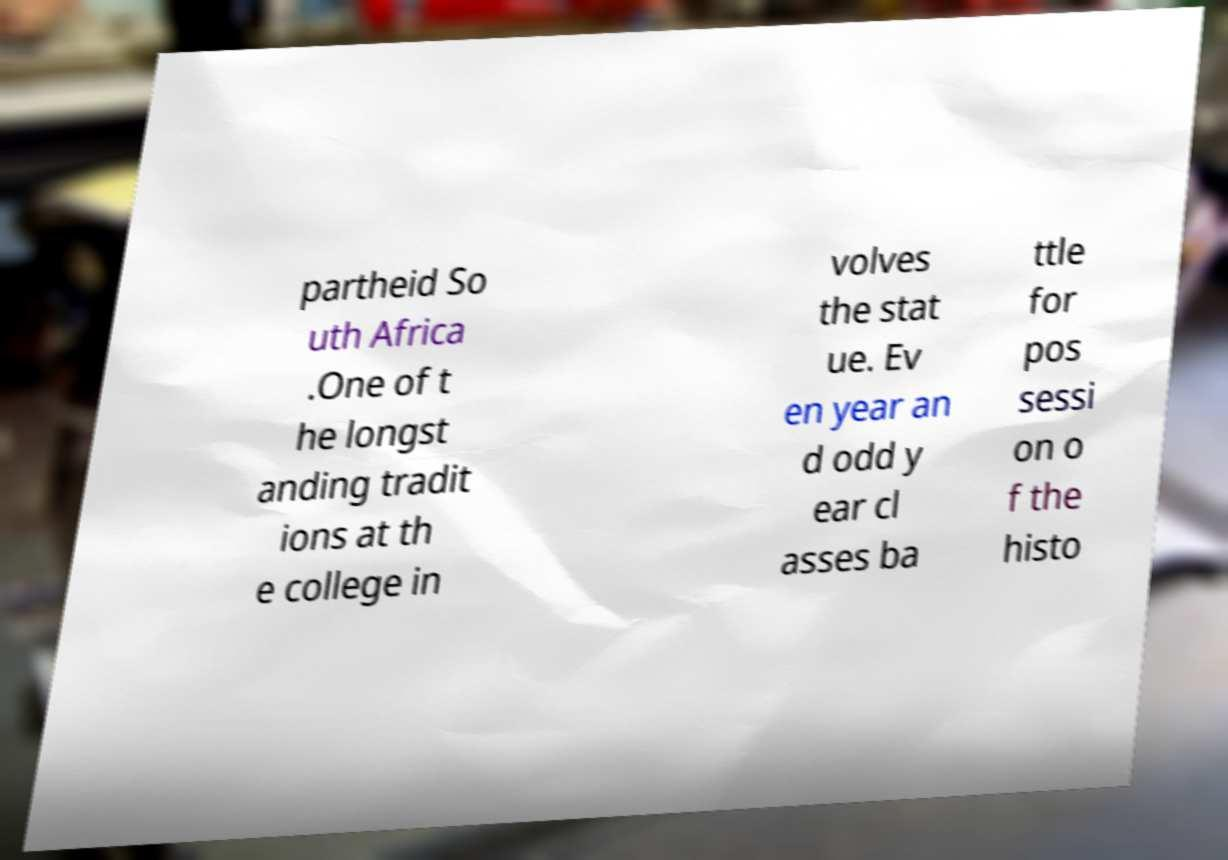There's text embedded in this image that I need extracted. Can you transcribe it verbatim? partheid So uth Africa .One of t he longst anding tradit ions at th e college in volves the stat ue. Ev en year an d odd y ear cl asses ba ttle for pos sessi on o f the histo 